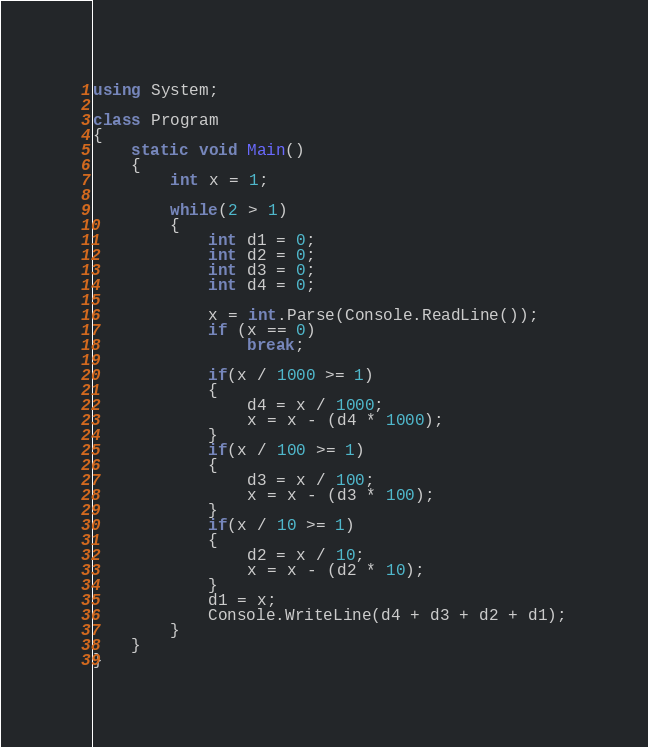Convert code to text. <code><loc_0><loc_0><loc_500><loc_500><_C#_>using System;

class Program
{
    static void Main()
    {
        int x = 1;

        while(2 > 1)
        {
            int d1 = 0;
            int d2 = 0;
            int d3 = 0;
            int d4 = 0;

            x = int.Parse(Console.ReadLine());
            if (x == 0)
                break;

            if(x / 1000 >= 1)
            {
                d4 = x / 1000;
                x = x - (d4 * 1000);
            }
            if(x / 100 >= 1)
            {
                d3 = x / 100;
                x = x - (d3 * 100);
            }
            if(x / 10 >= 1)
            {
                d2 = x / 10;
                x = x - (d2 * 10);
            }
            d1 = x;
            Console.WriteLine(d4 + d3 + d2 + d1);
        }
    }
}</code> 